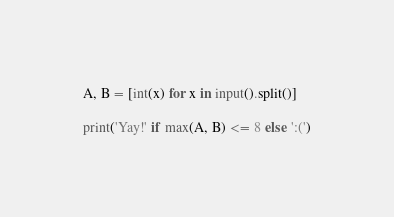Convert code to text. <code><loc_0><loc_0><loc_500><loc_500><_Python_>A, B = [int(x) for x in input().split()]

print('Yay!' if max(A, B) <= 8 else ':(')</code> 